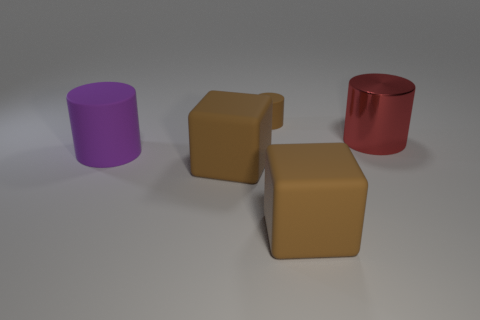Subtract all brown cylinders. How many cylinders are left? 2 Add 5 big red cylinders. How many objects exist? 10 Subtract all purple cylinders. How many cylinders are left? 2 Subtract all cylinders. How many objects are left? 2 Subtract all brown objects. Subtract all cyan shiny cubes. How many objects are left? 2 Add 2 tiny cylinders. How many tiny cylinders are left? 3 Add 3 brown cylinders. How many brown cylinders exist? 4 Subtract 0 gray spheres. How many objects are left? 5 Subtract all blue cylinders. Subtract all red cubes. How many cylinders are left? 3 